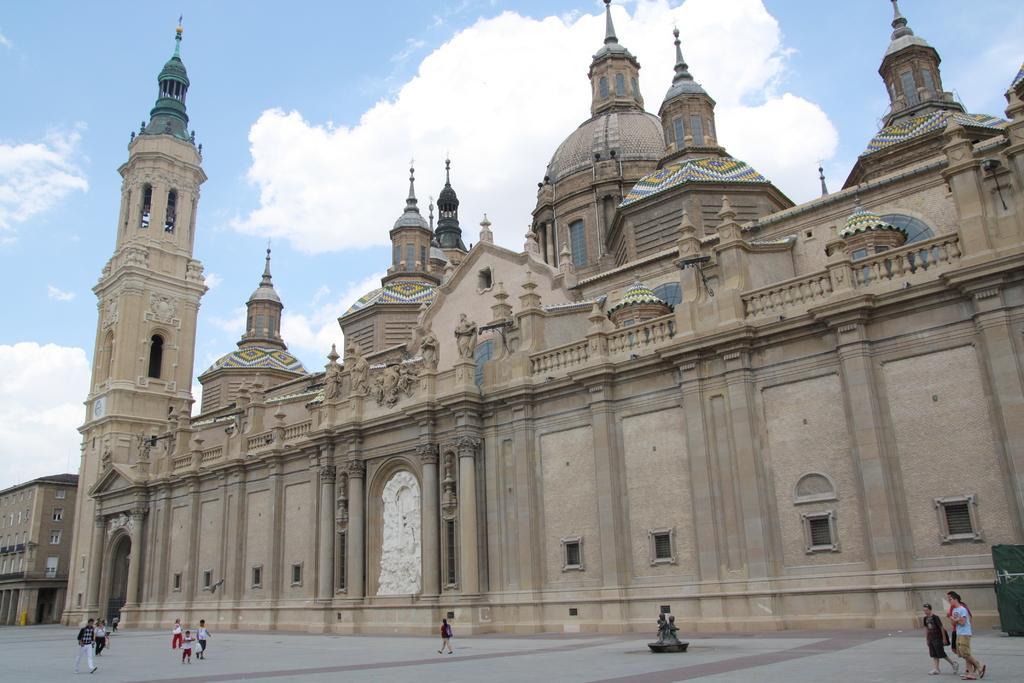Could you give a brief overview of what you see in this image? In this image I can see so many people walking on the road behind him there is a building. 